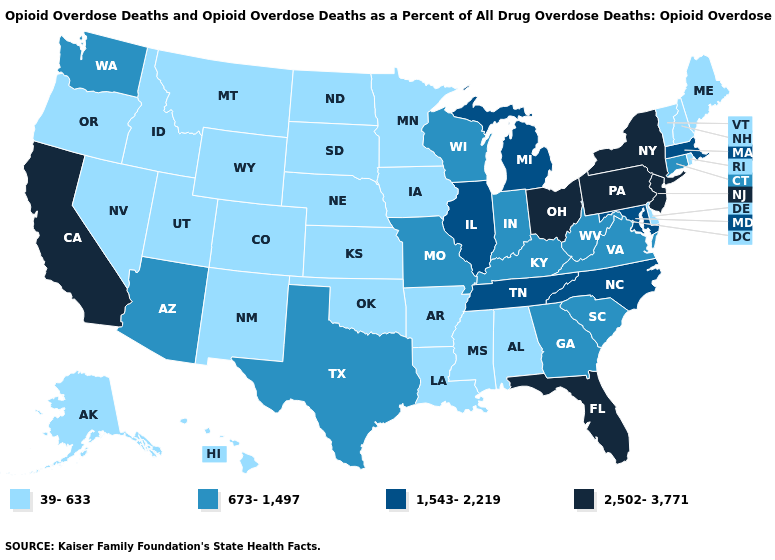Among the states that border Vermont , does Massachusetts have the lowest value?
Concise answer only. No. Which states have the lowest value in the West?
Be succinct. Alaska, Colorado, Hawaii, Idaho, Montana, Nevada, New Mexico, Oregon, Utah, Wyoming. Does Utah have the lowest value in the USA?
Answer briefly. Yes. Does New York have the same value as Florida?
Give a very brief answer. Yes. Does Hawaii have the highest value in the USA?
Keep it brief. No. Does the first symbol in the legend represent the smallest category?
Keep it brief. Yes. What is the lowest value in the USA?
Quick response, please. 39-633. What is the highest value in states that border Idaho?
Keep it brief. 673-1,497. What is the highest value in states that border West Virginia?
Concise answer only. 2,502-3,771. Does Ohio have the highest value in the MidWest?
Write a very short answer. Yes. Name the states that have a value in the range 1,543-2,219?
Quick response, please. Illinois, Maryland, Massachusetts, Michigan, North Carolina, Tennessee. What is the value of Kansas?
Keep it brief. 39-633. Name the states that have a value in the range 673-1,497?
Keep it brief. Arizona, Connecticut, Georgia, Indiana, Kentucky, Missouri, South Carolina, Texas, Virginia, Washington, West Virginia, Wisconsin. What is the lowest value in states that border Indiana?
Answer briefly. 673-1,497. What is the lowest value in the USA?
Concise answer only. 39-633. 